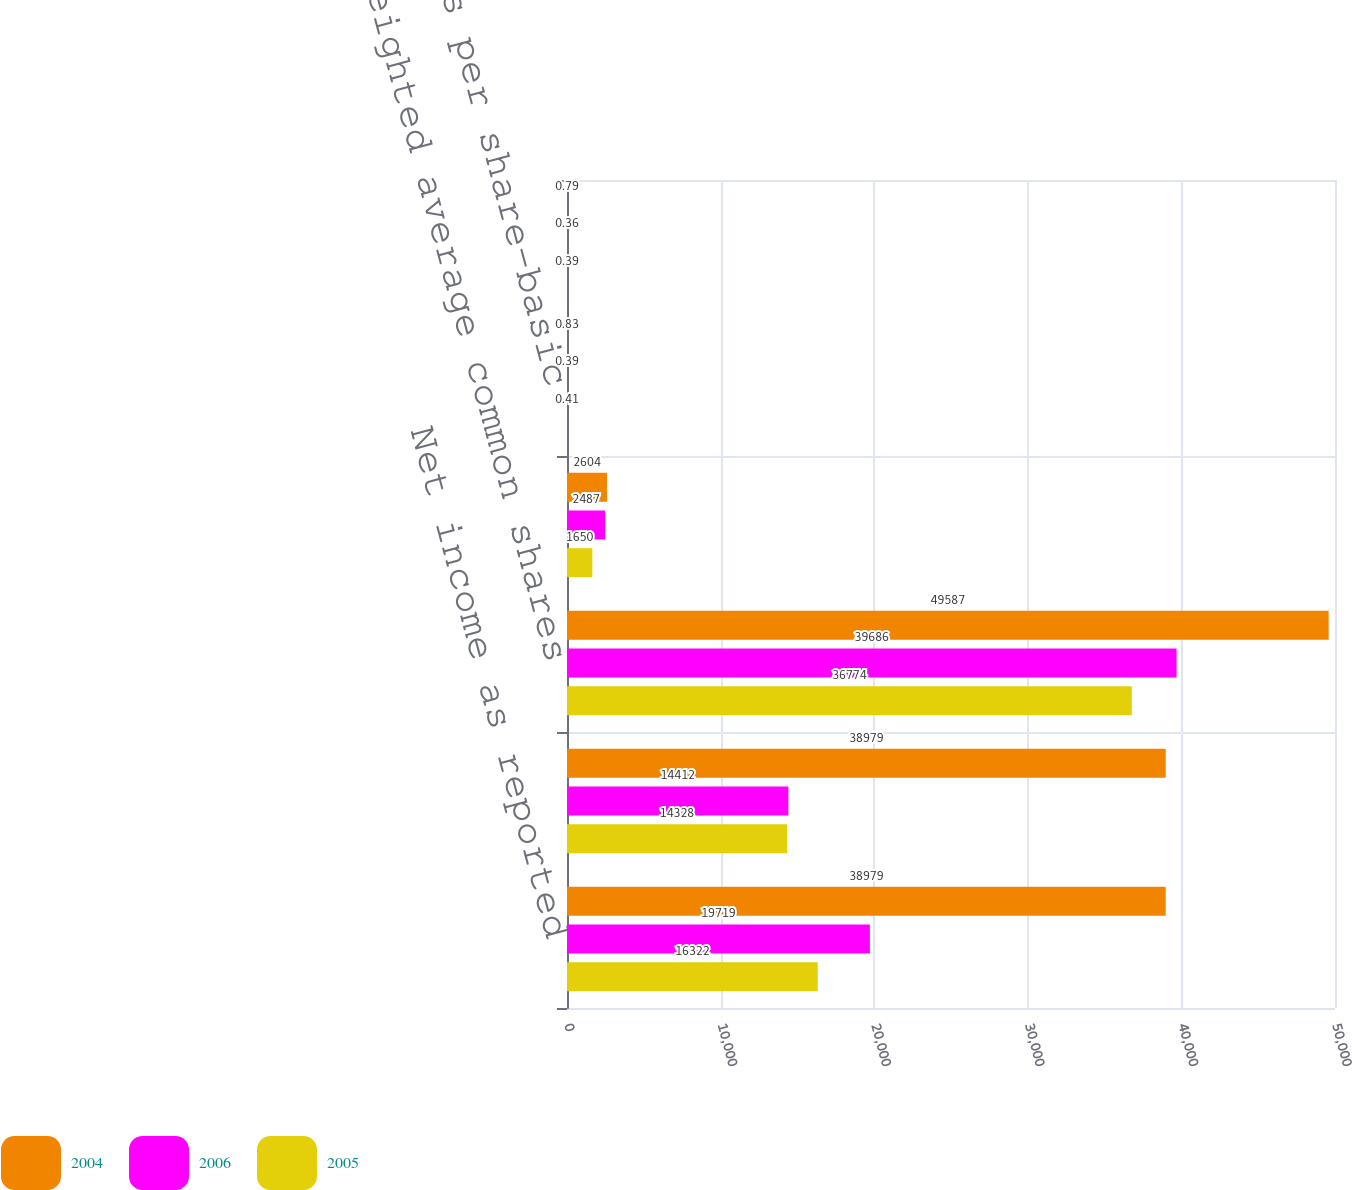Convert chart. <chart><loc_0><loc_0><loc_500><loc_500><stacked_bar_chart><ecel><fcel>Net income as reported<fcel>Net income available to common<fcel>Weighted average common shares<fcel>Effect of dilutive securities<fcel>Earnings per share-basic<fcel>Earnings per share-diluted<nl><fcel>2004<fcel>38979<fcel>38979<fcel>49587<fcel>2604<fcel>0.83<fcel>0.79<nl><fcel>2006<fcel>19719<fcel>14412<fcel>39686<fcel>2487<fcel>0.39<fcel>0.36<nl><fcel>2005<fcel>16322<fcel>14328<fcel>36774<fcel>1650<fcel>0.41<fcel>0.39<nl></chart> 